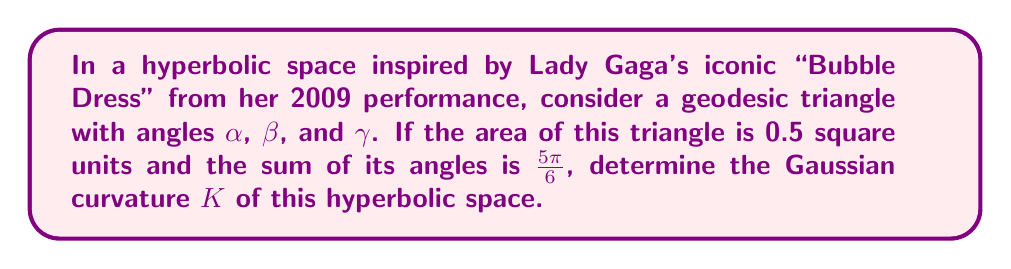Help me with this question. Let's approach this step-by-step:

1) In hyperbolic geometry, the area $A$ of a triangle is related to its angles and the Gaussian curvature $K$ by the Gauss-Bonnet formula:

   $$A = \frac{\alpha + \beta + \gamma - \pi}{-K}$$

2) We're given that the area $A = 0.5$ square units and the sum of angles $\alpha + \beta + \gamma = \frac{5\pi}{6}$.

3) Substituting these into the Gauss-Bonnet formula:

   $$0.5 = \frac{\frac{5\pi}{6} - \pi}{-K}$$

4) Simplify the numerator:

   $$0.5 = \frac{-\frac{\pi}{6}}{-K}$$

5) Simplify further:

   $$0.5 = \frac{\pi}{6K}$$

6) Multiply both sides by $K$:

   $$0.5K = \frac{\pi}{6}$$

7) Multiply both sides by 2:

   $$K = \frac{\pi}{3}$$

Therefore, the Gaussian curvature $K$ of this hyperbolic space is $\frac{\pi}{3}$.
Answer: $K = \frac{\pi}{3}$ 